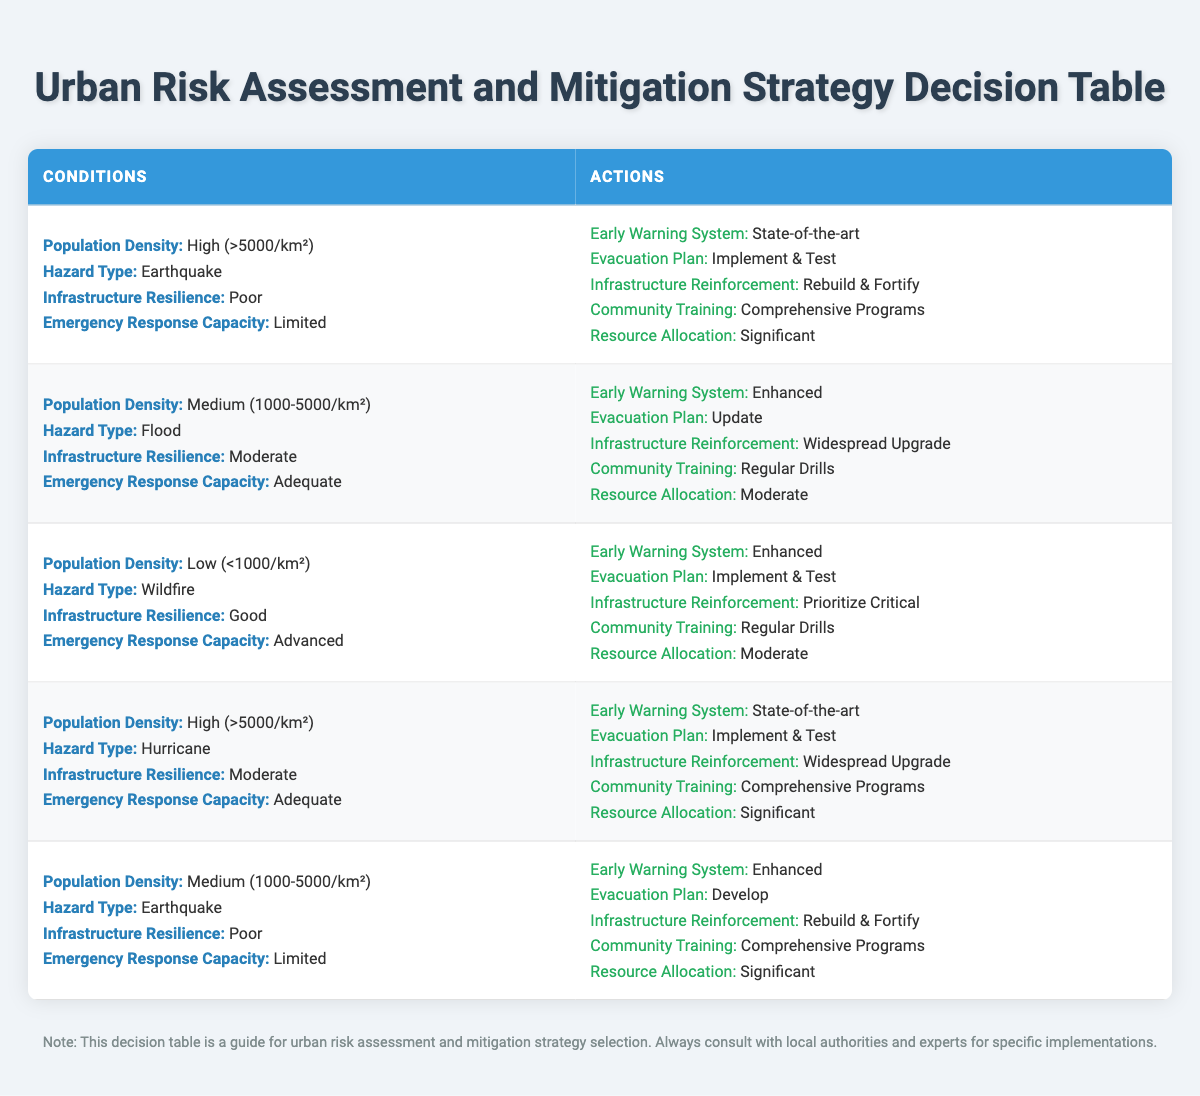What actions are recommended for areas with high population density and poor infrastructure resilience during an earthquake? From the table, when the conditions are a high population density, poor infrastructure resilience, and earthquake hazard type, the recommended actions are to implement a state-of-the-art early warning system, develop and test evacuation plans, rebuild and fortify infrastructure, conduct comprehensive community training, and allocate significant resources.
Answer: State-of-the-art early warning system, Implement & Test evacuation plan, Rebuild & Fortify infrastructure, Comprehensive Programs community training, Significant resource allocation What type of evacuation plan is suggested for medium-density areas facing floods with moderate infrastructure resilience? According to the table, if the area has a medium population density, is dealing with a flood hazard type, and has moderate infrastructure resilience, the suggested evacuation plan is to update the current plan.
Answer: Update evacuation plan Is the recommended community training for a low-density area with good infrastructure resilience facing a wildfire intensive or not? The table indicates that for a low-density area with good infrastructure resilience and wildfire as the hazard type, the community training action is to conduct regular drills, which is considered a moderate intensity training approach.
Answer: Not intensive How many different types of evacuation plans are suggested in total across the decision table? By examining the table's rules, we can count the instances of unique evacuation plan suggestions across different conditions. The plans mentioned are "Develop," "Update," and "Implement & Test," which gives a total of three unique types of evacuation plans.
Answer: Three For areas at high risk of hurricanes with moderate infrastructure resilience, what resources should be allocated? The decision table specifies that when dealing with high population density and hurricanes, resources should be allocated significantly. Thus, significant resources are advised to deal with this risk.
Answer: Significant resources should be allocated What is the relation between emergency response capacity and community training for areas with a medium population density and poor infrastructure resilience facing earthquakes? Analyzing the table, it shows that for medium population density, poor infrastructure resilience, and earthquake hazard, the emergency response capacity is limited, and the action recommended for community training is implementing comprehensive programs. This indicates that as response capacity is limited, more intensive training programs are suggested to enhance preparedness.
Answer: As response capacity is limited, comprehensive programs are suggested 